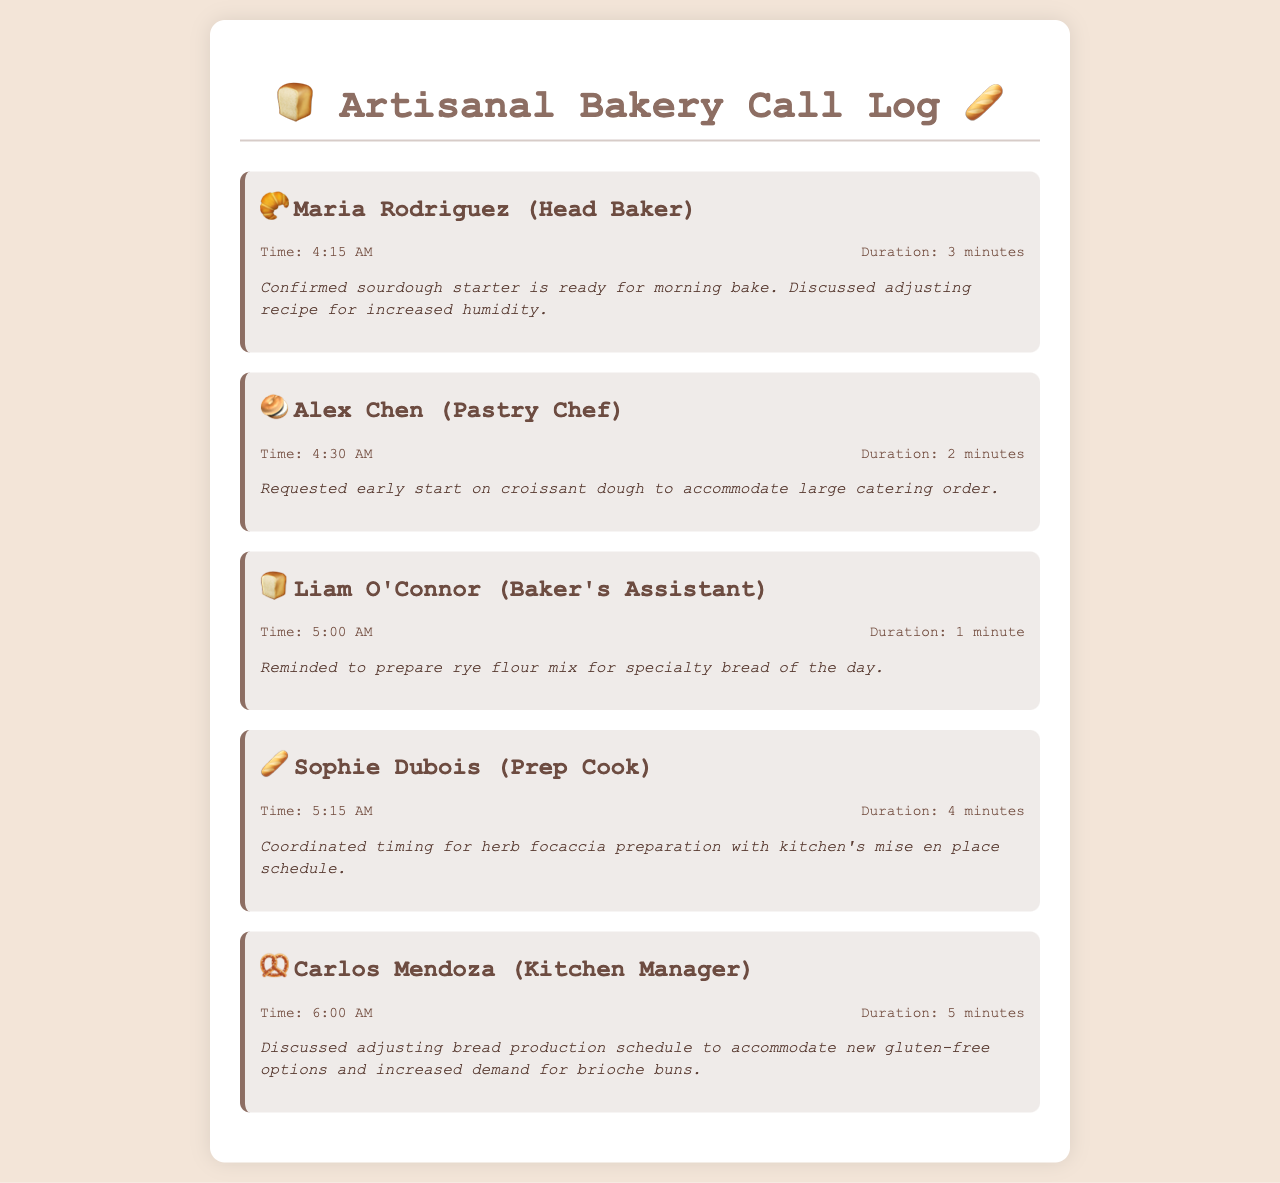What time did Maria Rodriguez call? The call log indicates that Maria Rodriguez, the Head Baker, made her call at 4:15 AM.
Answer: 4:15 AM What was discussed in Alex Chen's call? According to the summary, Alex Chen requested an early start on croissant dough due to a large catering order.
Answer: Early start on croissant dough How long was Liam O'Connor's call? The document states that Liam O'Connor's call duration was 1 minute.
Answer: 1 minute What preparation was coordinated during Sophie Dubois's call? The summary mentions that Sophie Dubois coordinated the timing for herb focaccia preparation with the kitchen's mise en place schedule.
Answer: Herb focaccia preparation Which kitchen staff member discussed gluten-free options? Carlos Mendoza, the Kitchen Manager, is noted to have discussed adjusting the bread production schedule to accommodate new gluten-free options.
Answer: Carlos Mendoza Why did Alex Chen request an early start? The document mentions that Alex Chen requested an early start due to a large catering order.
Answer: Large catering order What time did the last call take place? According to the log, the last call was made at 6:00 AM by Carlos Mendoza.
Answer: 6:00 AM How many minutes did Sophie Dubois's call last? The duration of Sophie Dubois's call, as stated in the document, was 4 minutes.
Answer: 4 minutes What specialty bread was mentioned in Liam O'Connor's call? The call log notes that Liam O'Connor was reminded to prepare the rye flour mix for the specialty bread of the day.
Answer: Rye flour mix 